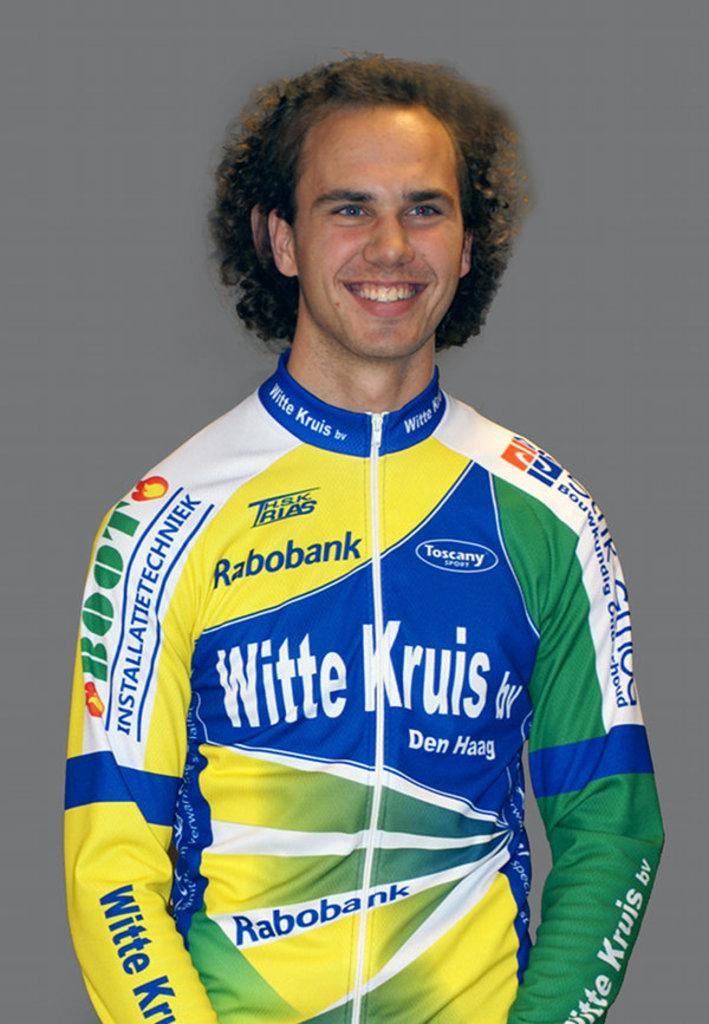<image>
Present a compact description of the photo's key features. A sportsman, Witte Kruis, who is wearing a jecket with his name and sponser's logo. 